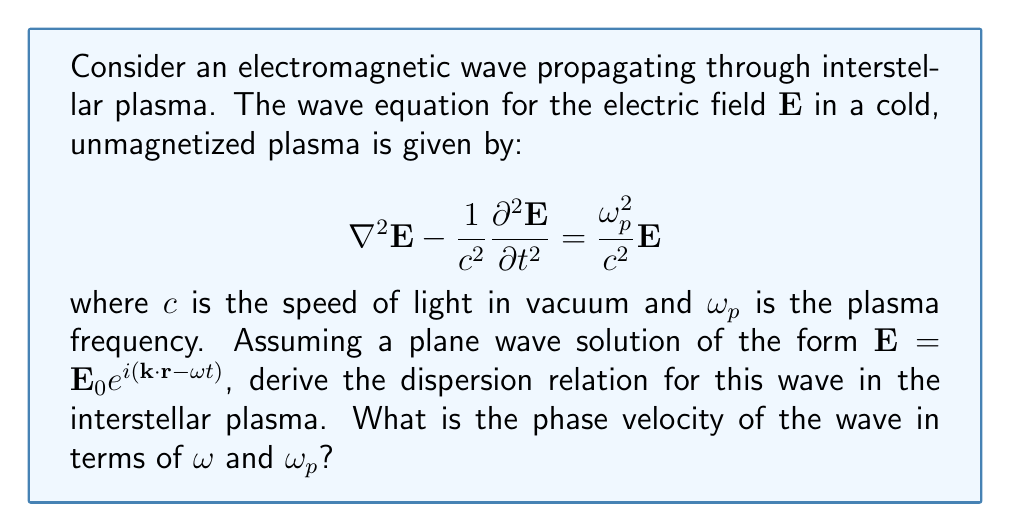Show me your answer to this math problem. Let's approach this step-by-step:

1) We start with the wave equation:

   $$\nabla^2\mathbf{E} - \frac{1}{c^2}\frac{\partial^2\mathbf{E}}{\partial t^2} = \frac{\omega_p^2}{c^2}\mathbf{E}$$

2) We assume a plane wave solution of the form:

   $$\mathbf{E} = \mathbf{E}_0 e^{i(\mathbf{k}\cdot\mathbf{r} - \omega t)}$$

3) Let's calculate the necessary derivatives:

   $\nabla^2\mathbf{E} = -k^2\mathbf{E}$
   $\frac{\partial^2\mathbf{E}}{\partial t^2} = -\omega^2\mathbf{E}$

4) Substituting these into the wave equation:

   $$-k^2\mathbf{E} + \frac{\omega^2}{c^2}\mathbf{E} = \frac{\omega_p^2}{c^2}\mathbf{E}$$

5) Cancelling $\mathbf{E}$ from both sides:

   $$-k^2 + \frac{\omega^2}{c^2} = \frac{\omega_p^2}{c^2}$$

6) Rearranging, we get the dispersion relation:

   $$k^2 = \frac{\omega^2 - \omega_p^2}{c^2}$$

7) The phase velocity is defined as $v_p = \frac{\omega}{k}$. Using the dispersion relation:

   $$v_p = \frac{\omega}{k} = \frac{\omega}{\sqrt{\frac{\omega^2 - \omega_p^2}{c^2}}} = c\sqrt{\frac{\omega^2}{\omega^2 - \omega_p^2}}$$

This is the phase velocity in terms of $\omega$ and $\omega_p$.
Answer: $v_p = c\sqrt{\frac{\omega^2}{\omega^2 - \omega_p^2}}$ 